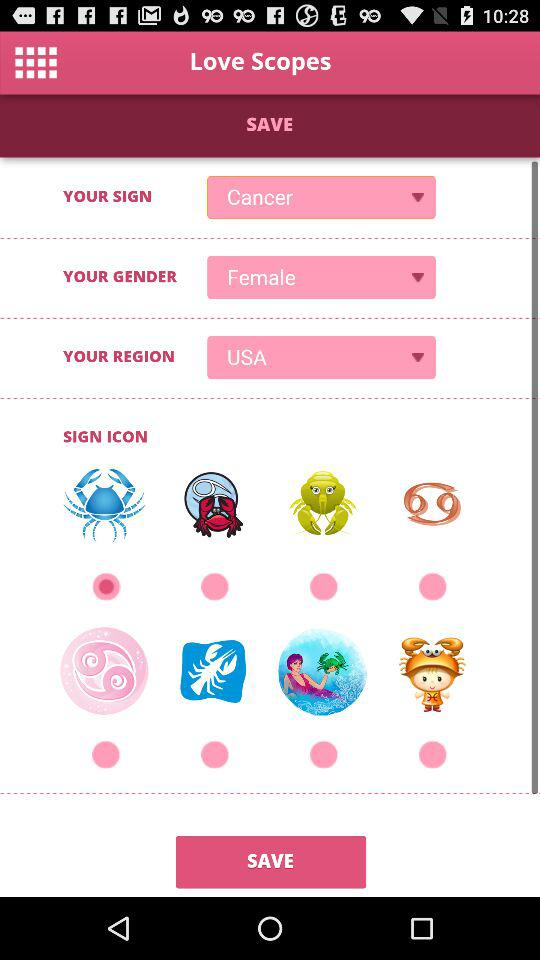What is your region? Your region is the USA. 